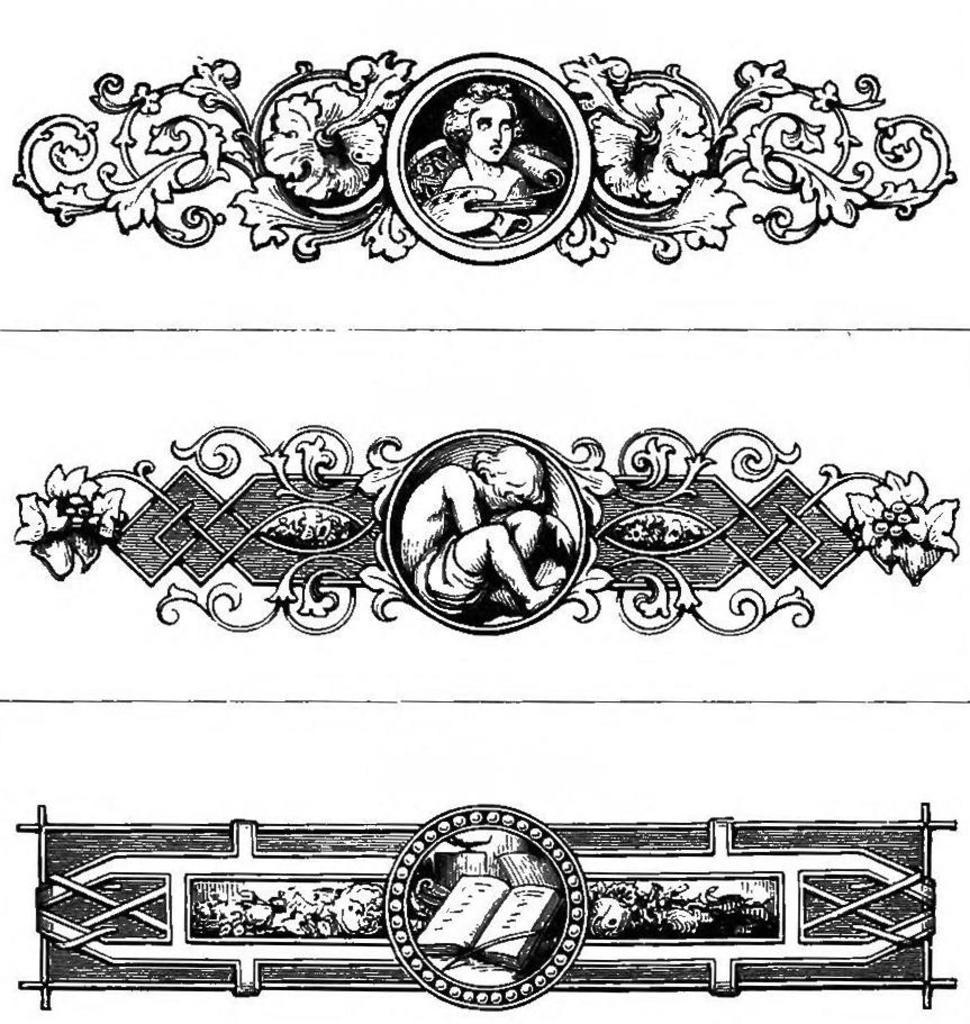How many different types of designs can be seen in the image? There are three different types of designs in the image. What colors are used in the designs? Some designs are black in color, while others are white and black in color. Can you see a sail in the image? There is no sail present in the image. What type of furniture can be seen in the image? There is no furniture present in the image. 